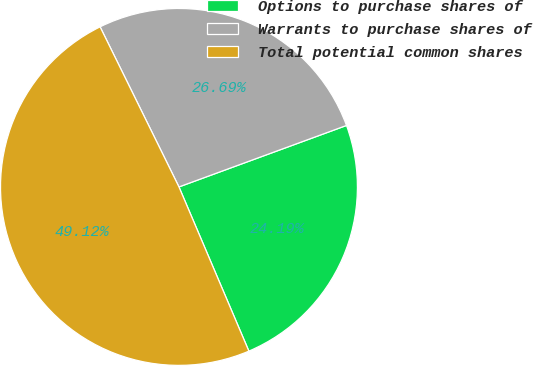Convert chart. <chart><loc_0><loc_0><loc_500><loc_500><pie_chart><fcel>Options to purchase shares of<fcel>Warrants to purchase shares of<fcel>Total potential common shares<nl><fcel>24.19%<fcel>26.69%<fcel>49.12%<nl></chart> 